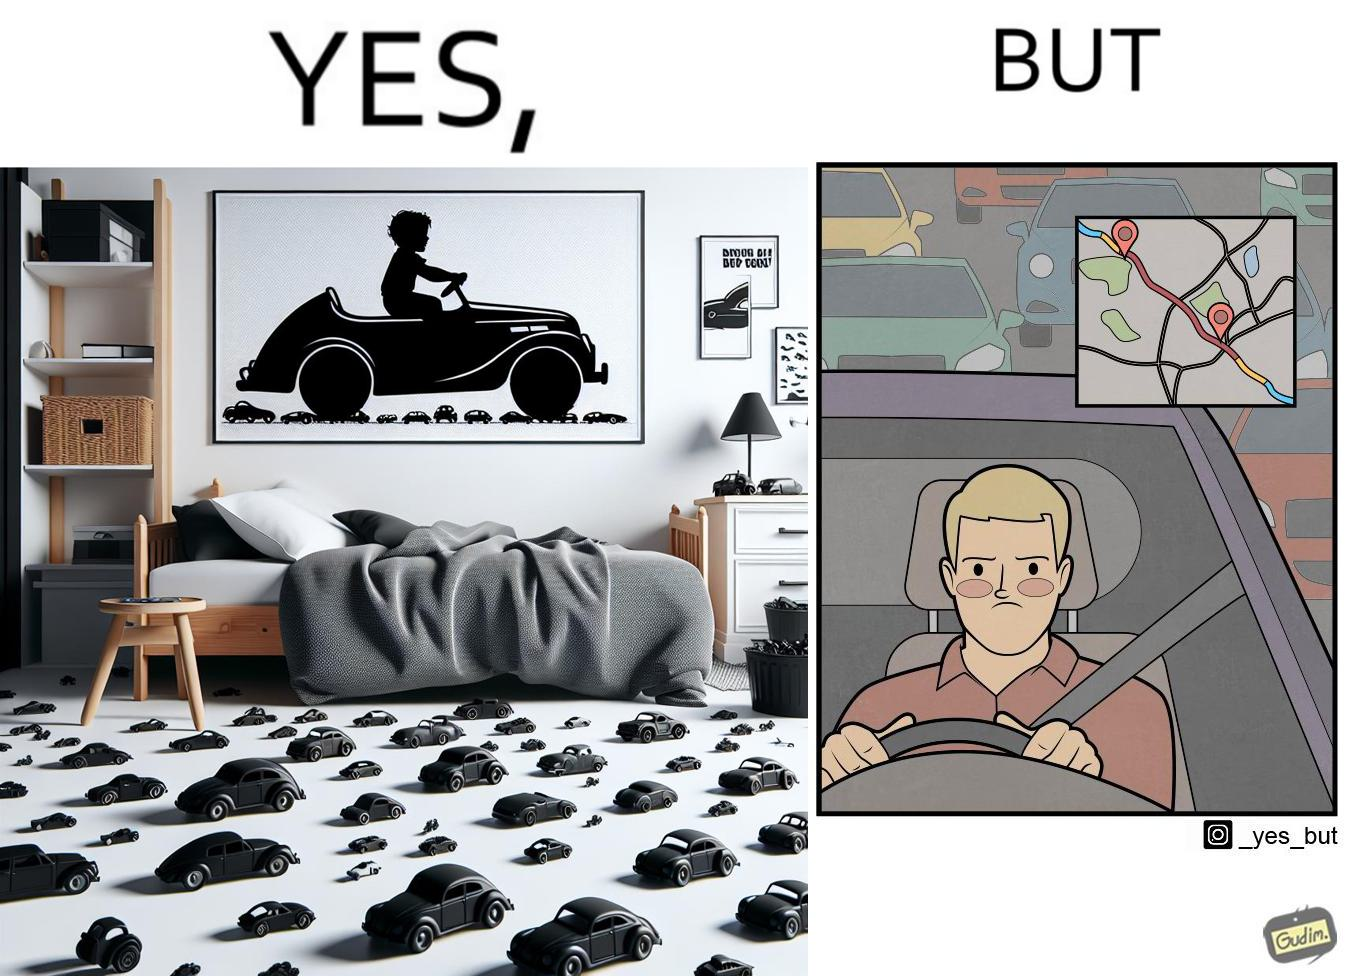Provide a description of this image. The image is funny beaucse while the person as a child enjoyed being around cars, had various small toy cars and even rode a bigger toy car, as as grown up he does not enjoy being in a car during a traffic jam while he is driving . 